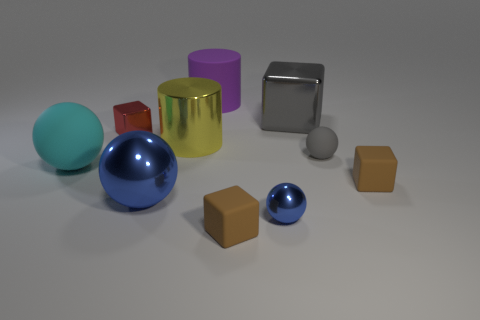Subtract all cylinders. How many objects are left? 8 Subtract all large cyan metal balls. Subtract all yellow metal things. How many objects are left? 9 Add 6 small gray spheres. How many small gray spheres are left? 7 Add 5 rubber cylinders. How many rubber cylinders exist? 6 Subtract 0 green spheres. How many objects are left? 10 